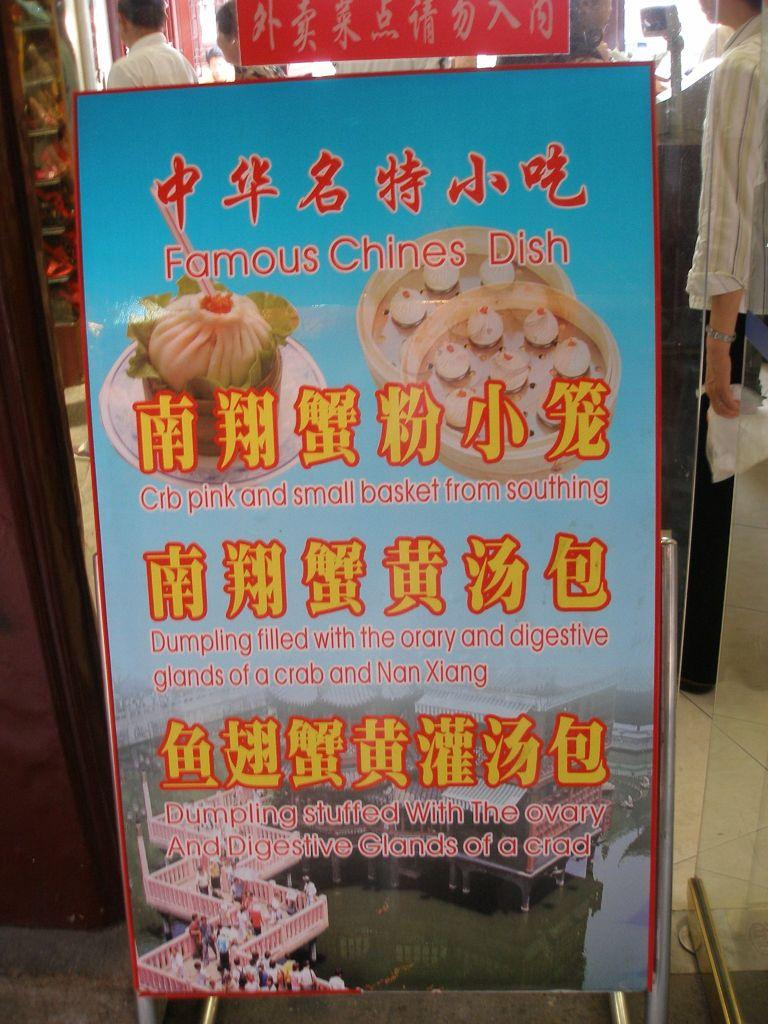What is on the board that is visible in the image? There is a board with writing in the image. What type of food is depicted in the image? There is a depiction of food in the image. What can be seen in the background of the image? There are buildings visible in the image. How many people are present in the image? There are people present in the image. Can you describe the people in the background of the image? There are people in the background of the image. What type of punishment is being administered to the lettuce in the image? There is no lettuce or punishment present in the image. Can you describe the snails crawling on the buildings in the image? There are no snails present in the image; only people, buildings, and a board with writing are visible. 